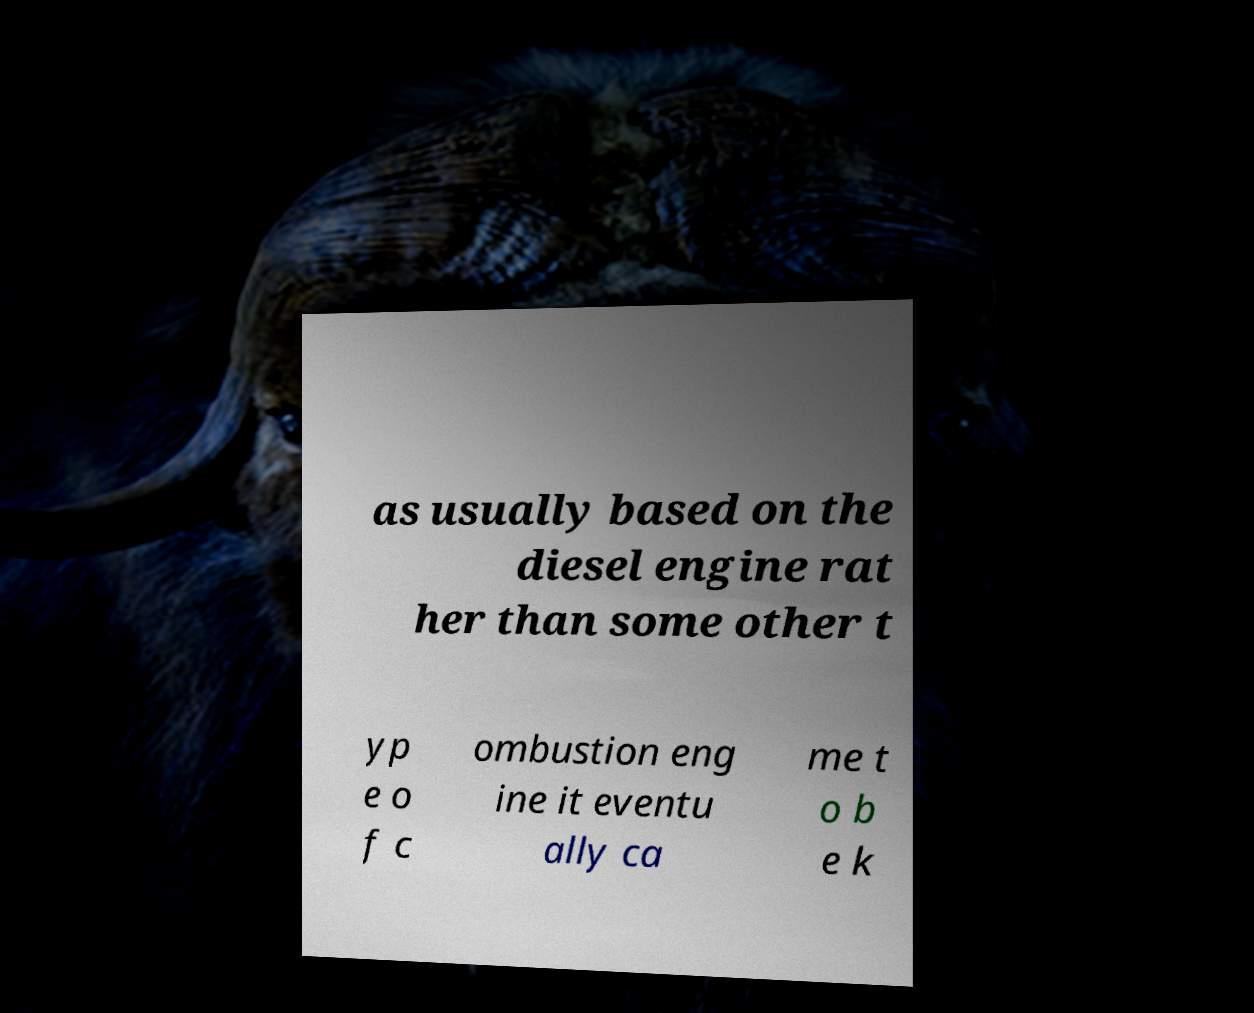Could you assist in decoding the text presented in this image and type it out clearly? as usually based on the diesel engine rat her than some other t yp e o f c ombustion eng ine it eventu ally ca me t o b e k 